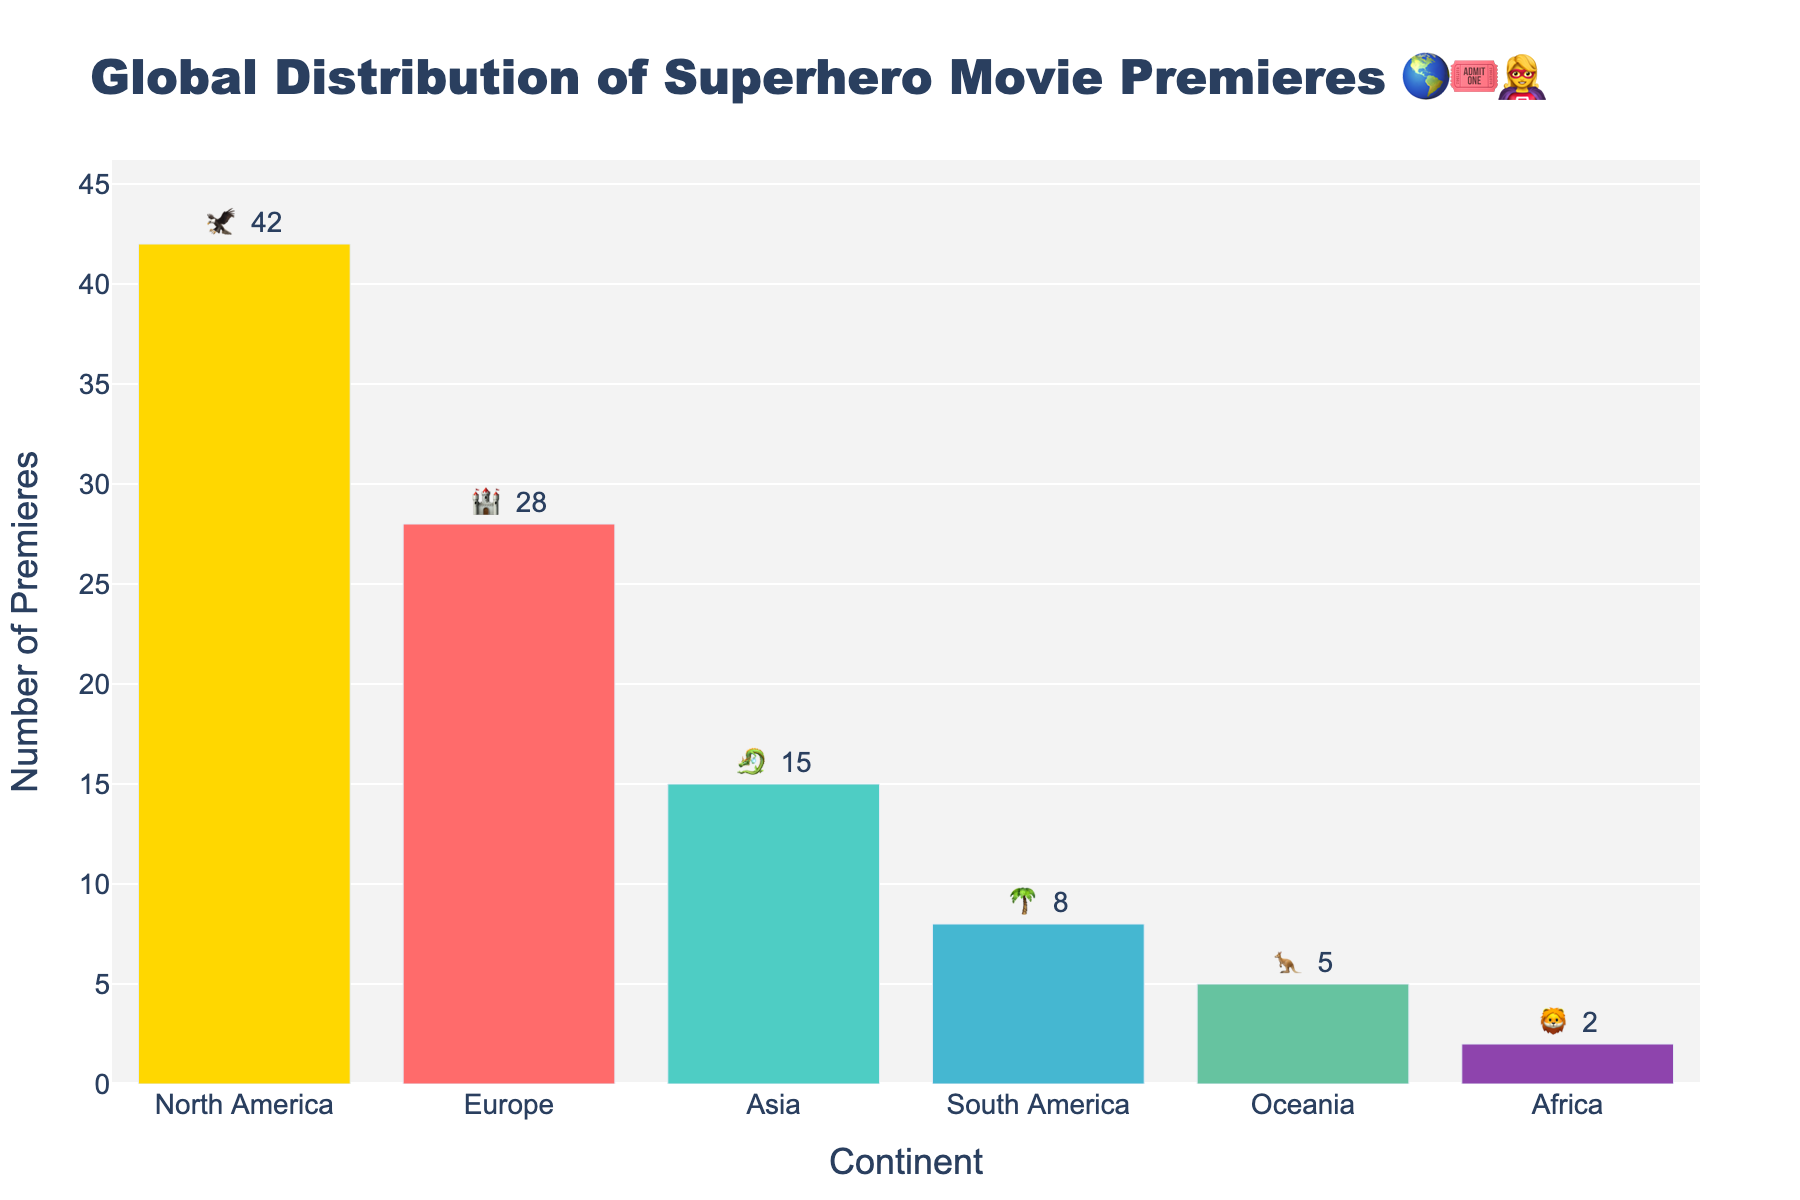- What is the title of the figure? The title is located at the top of the figure. It reads, "Global Distribution of Superhero Movie Premieres 🌎🎟️🦸‍♀️".
Answer: Global Distribution of Superhero Movie Premieres 🌎🎟️🦸‍♀️ - Which continent has the highest number of superhero movie premieres? By looking at the figure, the tallest bar represents North America. The label indicates 42 premieres.
Answer: North America - How many superhero movie premieres are there in Africa? The bar corresponding to Africa has a label and emoji indicating 2 premieres.
Answer: 2 - What is the combined number of premieres in Europe and Asia? The figure shows that Europe has 28 premieres and Asia has 15 premieres. Adding these together: 28 + 15 = 43.
Answer: 43 - Which continent has fewer premieres, South America or Oceania? Looking at the bars, South America has 8 premieres whereas Oceania has 5. Since 5 is less than 8, Oceania has fewer premieres.
Answer: Oceania - How many continents have premiered superhero movies? The figure presents bars for six continents: North America, Europe, Asia, South America, Oceania, and Africa. By counting, we get 6.
Answer: 6 - What is the total number of superhero movie premieres across all continents? Sum the number of premieres for each continent: 42 (North America) + 28 (Europe) + 15 (Asia) + 8 (South America) + 5 (Oceania) + 2 (Africa) = 100.
Answer: 100 - Which continent has the second-highest number of premieres? By comparing the height of the bars, North America has the most, and Europe has the second-highest number with 28 premieres.
Answer: Europe - What is the average number of premieres per continent, rounded to the nearest whole number? Total premieres are 100 across 6 continents. Average = Total Premieres / Number of Continents = 100 / 6 ≈ 16.7, rounded to 17.
Answer: 17 - How many more premieres does North America have compared to South America? North America has 42 premieres, and South America has 8. The difference is 42 - 8 = 34.
Answer: 34 